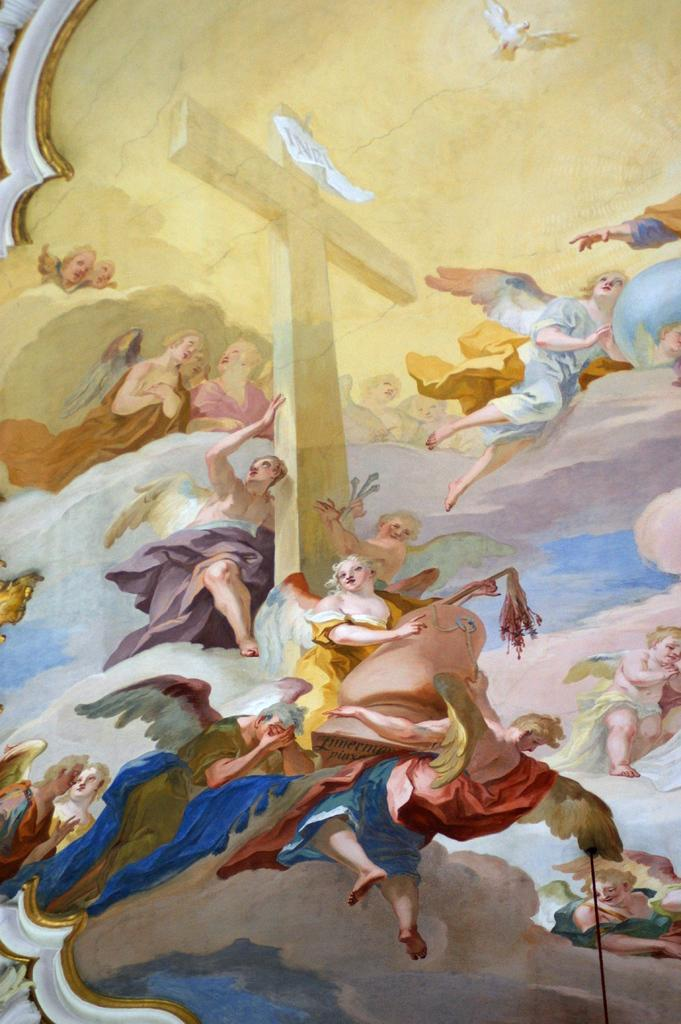What is the main subject of the painting in the image? There is a painting of a cross in the image. What are some people doing in relation to the cross? Some people are holding the cross in the image. What else is happening in the air in the image? Some people are flying in the air and there are birds flying in the air in the image. How many cakes are being served at the event in the image? There is no event or cakes present in the image; it features a painting of a cross with people holding it and others flying in the air. 